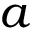<formula> <loc_0><loc_0><loc_500><loc_500>a</formula> 